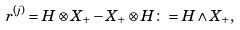<formula> <loc_0><loc_0><loc_500><loc_500>r ^ { ( j ) } = H \otimes X _ { + } - X _ { + } \otimes H \colon = H \wedge X _ { + } ,</formula> 